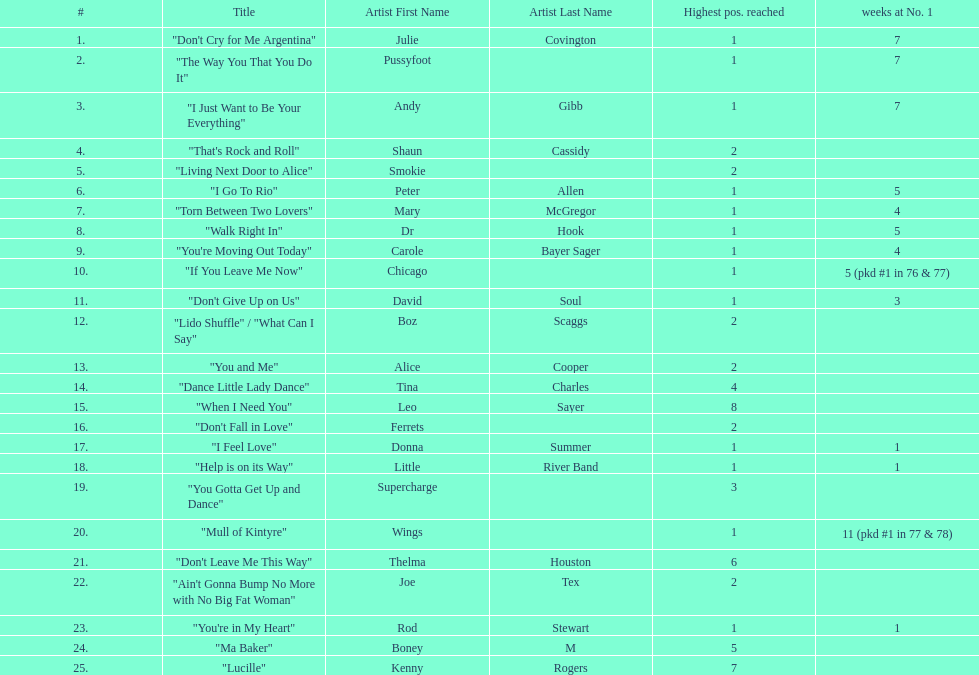Which three artists had a single at number 1 for at least 7 weeks on the australian singles charts in 1977? Julie Covington, Pussyfoot, Andy Gibb. 